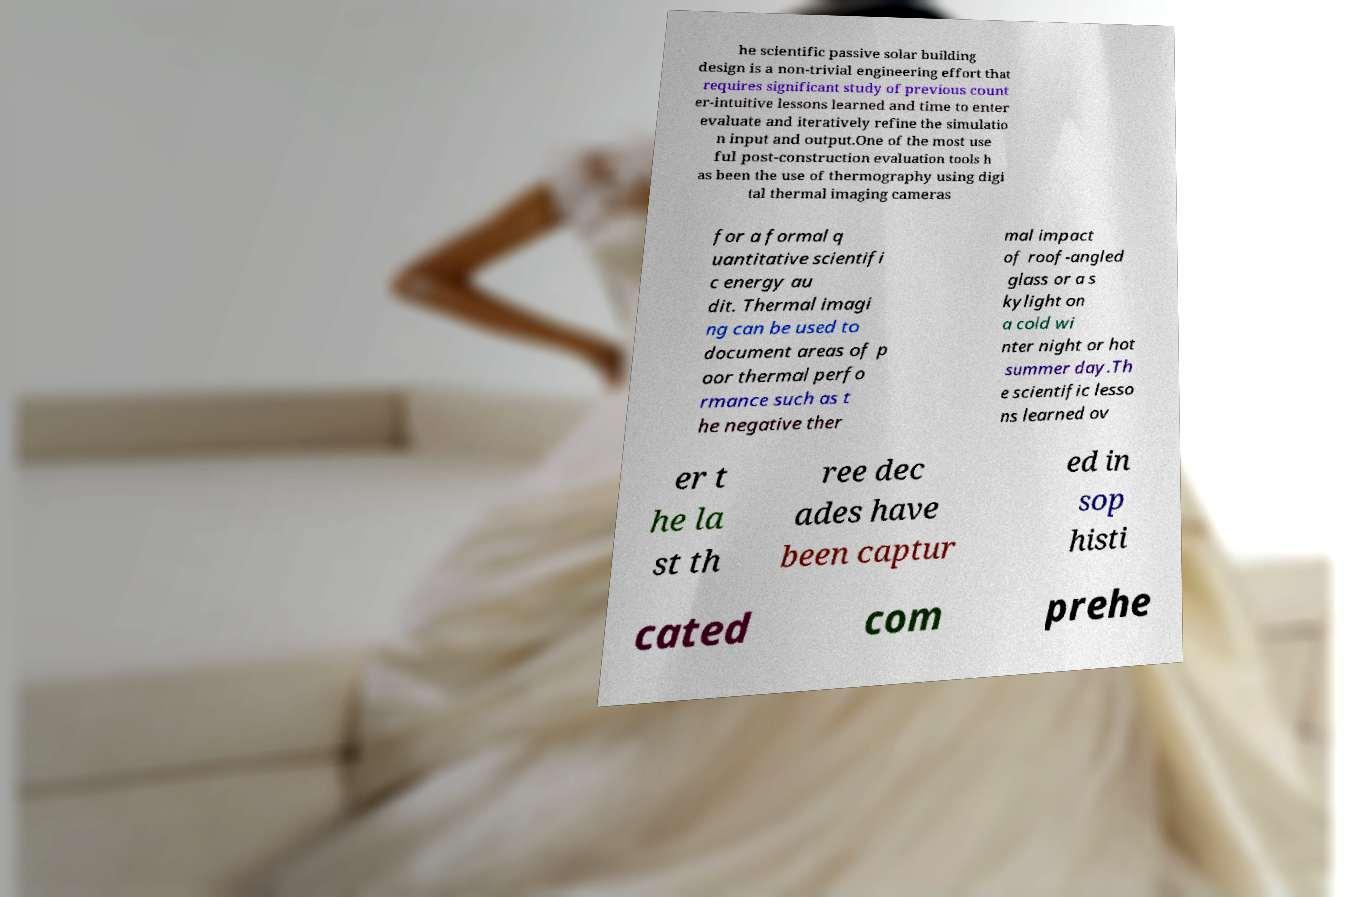Can you accurately transcribe the text from the provided image for me? he scientific passive solar building design is a non-trivial engineering effort that requires significant study of previous count er-intuitive lessons learned and time to enter evaluate and iteratively refine the simulatio n input and output.One of the most use ful post-construction evaluation tools h as been the use of thermography using digi tal thermal imaging cameras for a formal q uantitative scientifi c energy au dit. Thermal imagi ng can be used to document areas of p oor thermal perfo rmance such as t he negative ther mal impact of roof-angled glass or a s kylight on a cold wi nter night or hot summer day.Th e scientific lesso ns learned ov er t he la st th ree dec ades have been captur ed in sop histi cated com prehe 